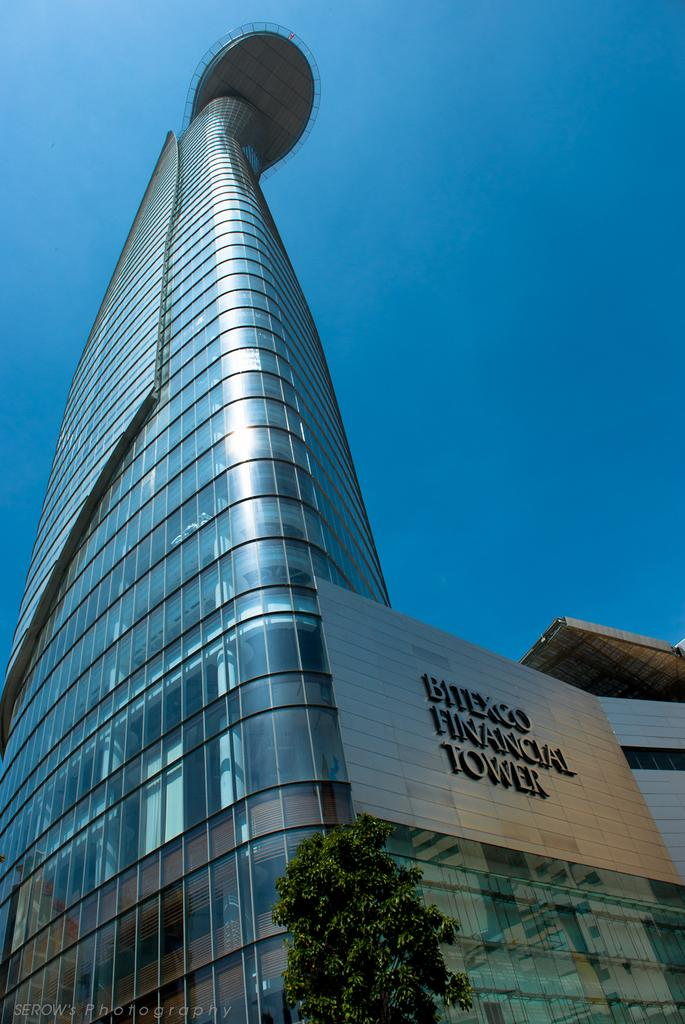What type of plant can be seen in the image? There is a tree in the image. What is the color of the tree? The tree is green. What type of structure is visible in the background of the image? There is a glass building in the background of the image. What is the color of the sky in the image? The sky is blue. What type of food is being served on a receipt in the image? There is no food or receipt present in the image. 